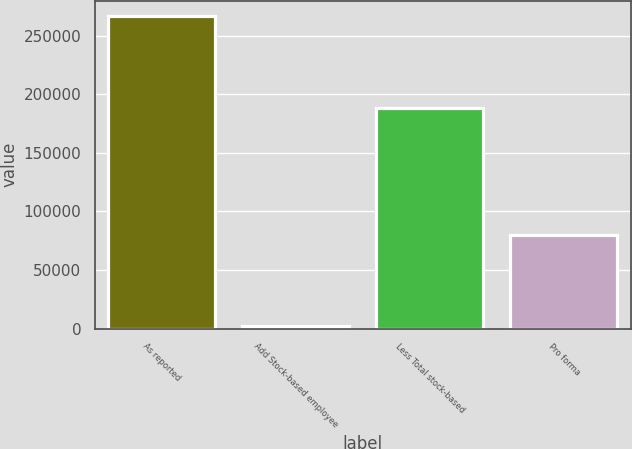Convert chart. <chart><loc_0><loc_0><loc_500><loc_500><bar_chart><fcel>As reported<fcel>Add Stock-based employee<fcel>Less Total stock-based<fcel>Pro forma<nl><fcel>266344<fcel>1837<fcel>188427<fcel>79754<nl></chart> 